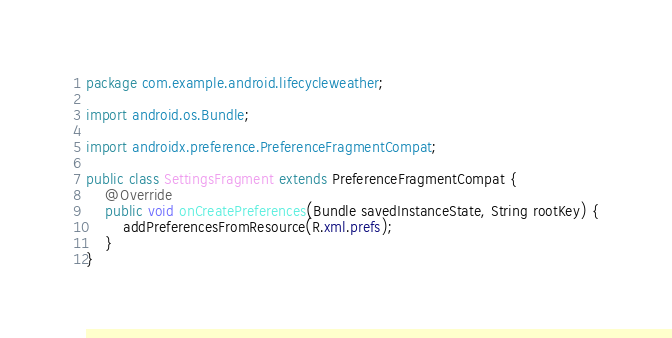Convert code to text. <code><loc_0><loc_0><loc_500><loc_500><_Java_>package com.example.android.lifecycleweather;

import android.os.Bundle;

import androidx.preference.PreferenceFragmentCompat;

public class SettingsFragment extends PreferenceFragmentCompat {
    @Override
    public void onCreatePreferences(Bundle savedInstanceState, String rootKey) {
        addPreferencesFromResource(R.xml.prefs);
    }
}
</code> 